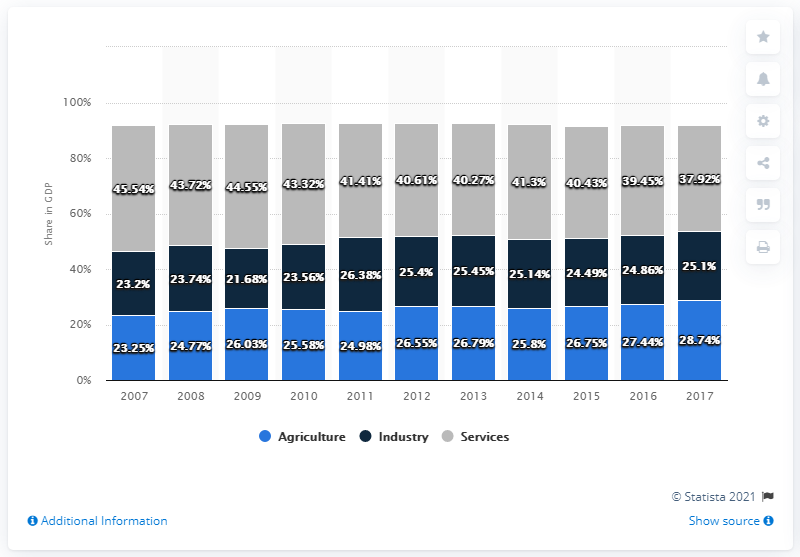Identify some key points in this picture. The difference between the highest GDP in the Agriculture sector and the lowest GDP in the Industry over the years has been 5.11. In 2017, agriculture accounted for 28.74% of Tanzania's gross domestic product. In Tanzania, the agriculture sector recorded the highest GDP in 2017. 